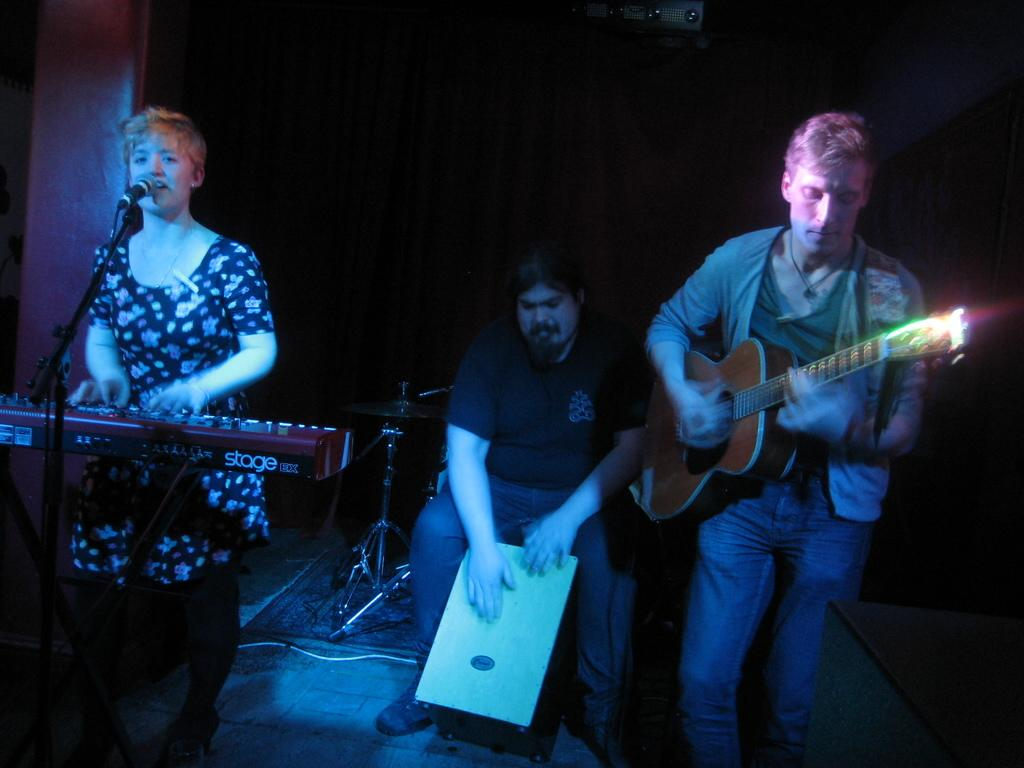What are the persons in the image doing? The persons in the image are playing musical instruments. What object is located in the middle of the image? There is a microphone in the middle of the image. Can you see any signs of thunder in the image? There is no mention of thunder or any weather-related elements in the image. The focus is on the persons playing musical instruments and the microphone. 